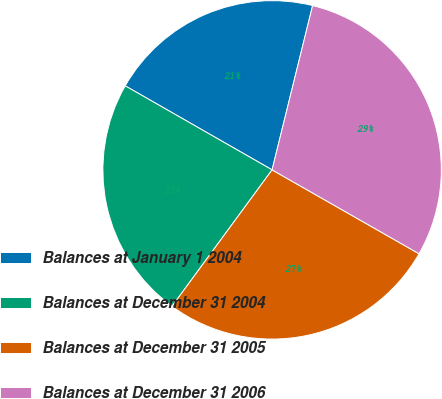Convert chart. <chart><loc_0><loc_0><loc_500><loc_500><pie_chart><fcel>Balances at January 1 2004<fcel>Balances at December 31 2004<fcel>Balances at December 31 2005<fcel>Balances at December 31 2006<nl><fcel>20.58%<fcel>23.2%<fcel>26.82%<fcel>29.41%<nl></chart> 